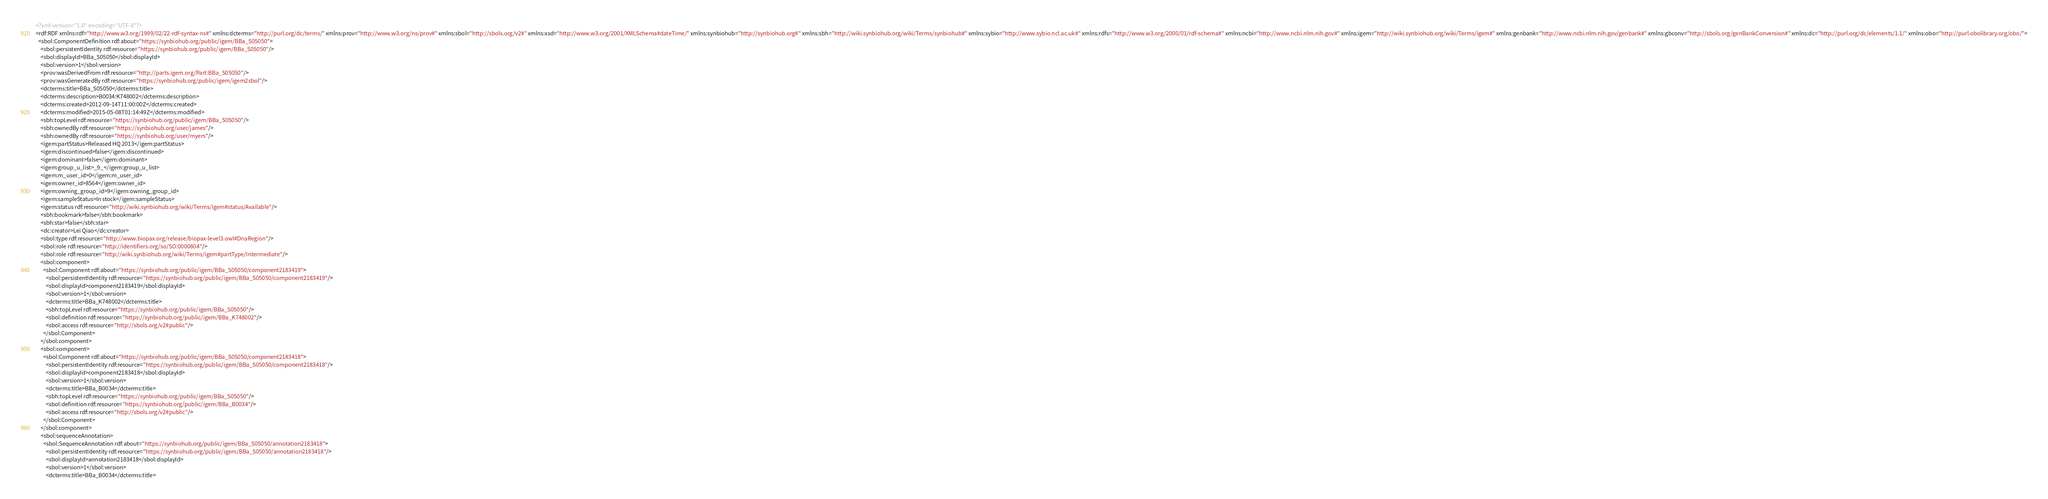Convert code to text. <code><loc_0><loc_0><loc_500><loc_500><_XML_><?xml version="1.0" encoding="UTF-8"?>
<rdf:RDF xmlns:rdf="http://www.w3.org/1999/02/22-rdf-syntax-ns#" xmlns:dcterms="http://purl.org/dc/terms/" xmlns:prov="http://www.w3.org/ns/prov#" xmlns:sbol="http://sbols.org/v2#" xmlns:xsd="http://www.w3.org/2001/XMLSchema#dateTime/" xmlns:synbiohub="http://synbiohub.org#" xmlns:sbh="http://wiki.synbiohub.org/wiki/Terms/synbiohub#" xmlns:sybio="http://www.sybio.ncl.ac.uk#" xmlns:rdfs="http://www.w3.org/2000/01/rdf-schema#" xmlns:ncbi="http://www.ncbi.nlm.nih.gov#" xmlns:igem="http://wiki.synbiohub.org/wiki/Terms/igem#" xmlns:genbank="http://www.ncbi.nlm.nih.gov/genbank#" xmlns:gbconv="http://sbols.org/genBankConversion#" xmlns:dc="http://purl.org/dc/elements/1.1/" xmlns:obo="http://purl.obolibrary.org/obo/">
  <sbol:ComponentDefinition rdf:about="https://synbiohub.org/public/igem/BBa_S05050">
    <sbol:persistentIdentity rdf:resource="https://synbiohub.org/public/igem/BBa_S05050"/>
    <sbol:displayId>BBa_S05050</sbol:displayId>
    <sbol:version>1</sbol:version>
    <prov:wasDerivedFrom rdf:resource="http://parts.igem.org/Part:BBa_S05050"/>
    <prov:wasGeneratedBy rdf:resource="https://synbiohub.org/public/igem/igem2sbol"/>
    <dcterms:title>BBa_S05050</dcterms:title>
    <dcterms:description>B0034:K748002</dcterms:description>
    <dcterms:created>2012-09-14T11:00:00Z</dcterms:created>
    <dcterms:modified>2015-05-08T01:14:49Z</dcterms:modified>
    <sbh:topLevel rdf:resource="https://synbiohub.org/public/igem/BBa_S05050"/>
    <sbh:ownedBy rdf:resource="https://synbiohub.org/user/james"/>
    <sbh:ownedBy rdf:resource="https://synbiohub.org/user/myers"/>
    <igem:partStatus>Released HQ 2013</igem:partStatus>
    <igem:discontinued>false</igem:discontinued>
    <igem:dominant>false</igem:dominant>
    <igem:group_u_list>_9_</igem:group_u_list>
    <igem:m_user_id>0</igem:m_user_id>
    <igem:owner_id>8564</igem:owner_id>
    <igem:owning_group_id>9</igem:owning_group_id>
    <igem:sampleStatus>In stock</igem:sampleStatus>
    <igem:status rdf:resource="http://wiki.synbiohub.org/wiki/Terms/igem#status/Available"/>
    <sbh:bookmark>false</sbh:bookmark>
    <sbh:star>false</sbh:star>
    <dc:creator>Lei Qiao</dc:creator>
    <sbol:type rdf:resource="http://www.biopax.org/release/biopax-level3.owl#DnaRegion"/>
    <sbol:role rdf:resource="http://identifiers.org/so/SO:0000804"/>
    <sbol:role rdf:resource="http://wiki.synbiohub.org/wiki/Terms/igem#partType/Intermediate"/>
    <sbol:component>
      <sbol:Component rdf:about="https://synbiohub.org/public/igem/BBa_S05050/component2183419">
        <sbol:persistentIdentity rdf:resource="https://synbiohub.org/public/igem/BBa_S05050/component2183419"/>
        <sbol:displayId>component2183419</sbol:displayId>
        <sbol:version>1</sbol:version>
        <dcterms:title>BBa_K748002</dcterms:title>
        <sbh:topLevel rdf:resource="https://synbiohub.org/public/igem/BBa_S05050"/>
        <sbol:definition rdf:resource="https://synbiohub.org/public/igem/BBa_K748002"/>
        <sbol:access rdf:resource="http://sbols.org/v2#public"/>
      </sbol:Component>
    </sbol:component>
    <sbol:component>
      <sbol:Component rdf:about="https://synbiohub.org/public/igem/BBa_S05050/component2183418">
        <sbol:persistentIdentity rdf:resource="https://synbiohub.org/public/igem/BBa_S05050/component2183418"/>
        <sbol:displayId>component2183418</sbol:displayId>
        <sbol:version>1</sbol:version>
        <dcterms:title>BBa_B0034</dcterms:title>
        <sbh:topLevel rdf:resource="https://synbiohub.org/public/igem/BBa_S05050"/>
        <sbol:definition rdf:resource="https://synbiohub.org/public/igem/BBa_B0034"/>
        <sbol:access rdf:resource="http://sbols.org/v2#public"/>
      </sbol:Component>
    </sbol:component>
    <sbol:sequenceAnnotation>
      <sbol:SequenceAnnotation rdf:about="https://synbiohub.org/public/igem/BBa_S05050/annotation2183418">
        <sbol:persistentIdentity rdf:resource="https://synbiohub.org/public/igem/BBa_S05050/annotation2183418"/>
        <sbol:displayId>annotation2183418</sbol:displayId>
        <sbol:version>1</sbol:version>
        <dcterms:title>BBa_B0034</dcterms:title></code> 